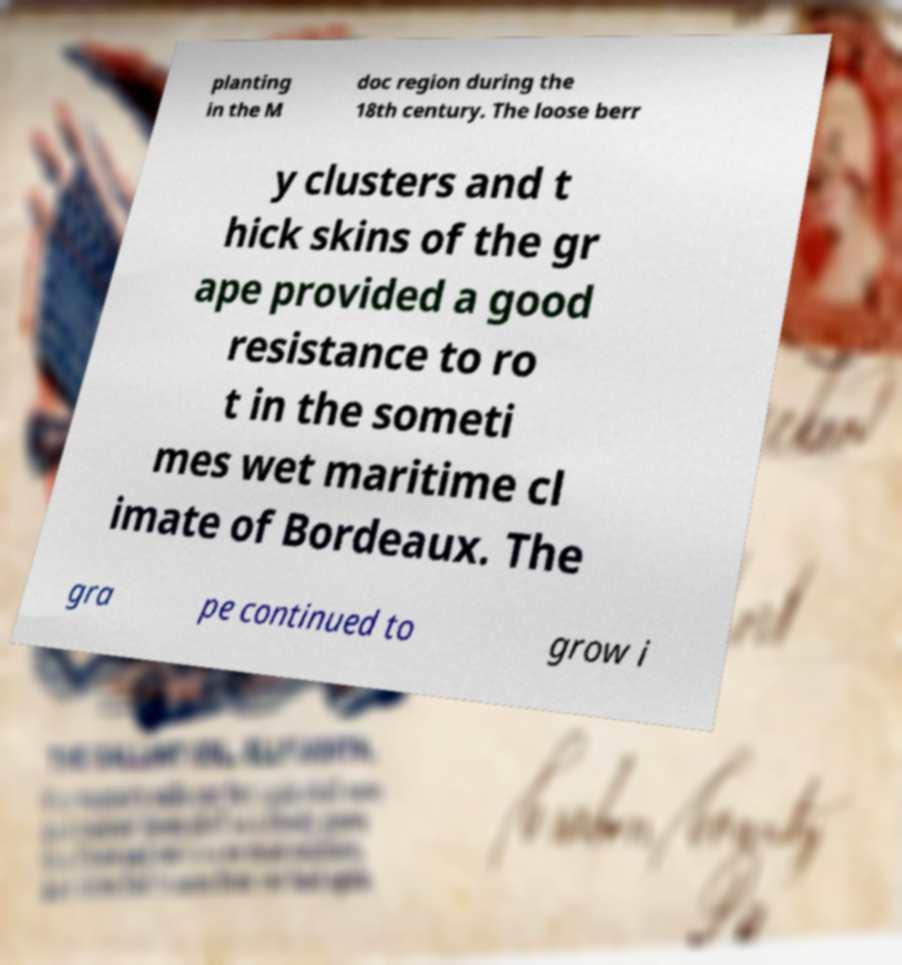Can you accurately transcribe the text from the provided image for me? planting in the M doc region during the 18th century. The loose berr y clusters and t hick skins of the gr ape provided a good resistance to ro t in the someti mes wet maritime cl imate of Bordeaux. The gra pe continued to grow i 